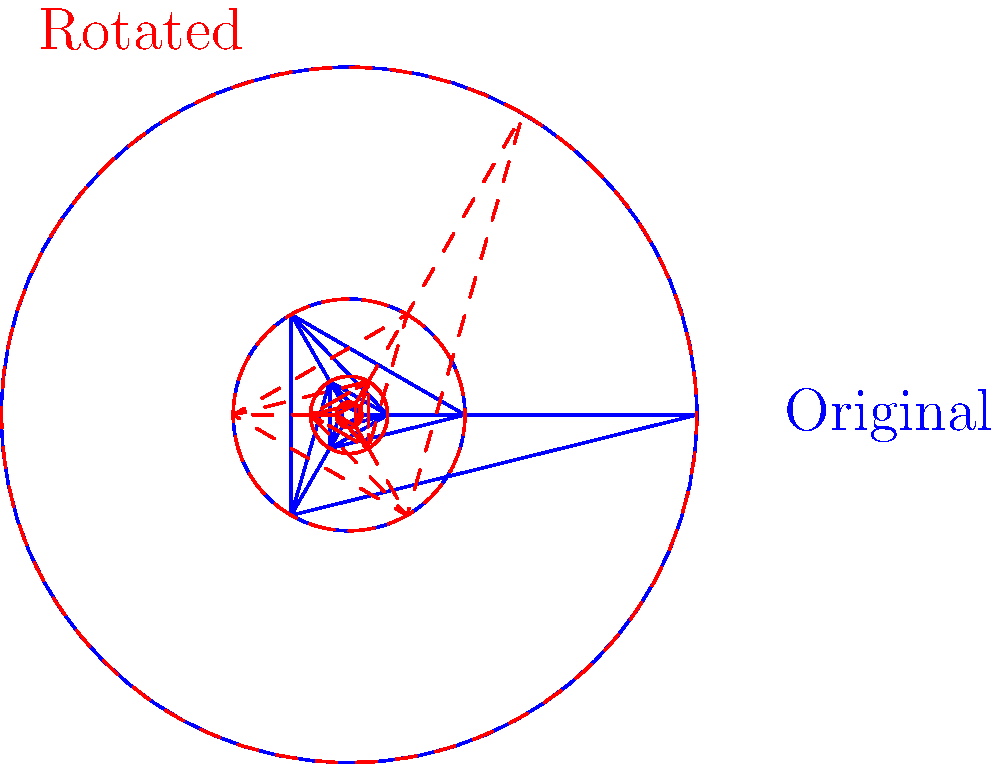In the context of psychedelic visuals often experienced in 90s rave culture, consider the fractal pattern shown. If this pattern undergoes a rotation transformation of 60° clockwise around its center, what group theory concept best describes the relationship between the original blue pattern and the transformed red pattern? To answer this question, let's break it down step-by-step:

1. First, we need to understand what we're looking at. The blue pattern is the original fractal, and the red dashed pattern is the result of rotating the blue pattern by 60° clockwise.

2. In group theory, transformations that preserve the structure of an object are called symmetries. These symmetries form a group under composition.

3. The key observation here is that after the 60° rotation, the overall shape of the fractal appears identical to the original, just in a different orientation.

4. This property, where an object looks the same after a certain amount of rotation, is called rotational symmetry.

5. More specifically, since a full 360° rotation would require six 60° rotations to return to the original position, this fractal has 6-fold rotational symmetry.

6. In group theory terms, the set of all rotations that leave the fractal unchanged forms a cyclic group of order 6, often denoted as $C_6$ or $\mathbb{Z}_6$.

7. The relationship between the original blue pattern and the rotated red pattern is that they are elements of the same orbit under the action of this cyclic group on the set of all possible orientations of the fractal.

8. This concept, where different states of an object under a group action are considered equivalent, is called orbit equivalence.
Answer: Orbit equivalence 